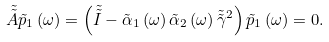<formula> <loc_0><loc_0><loc_500><loc_500>\tilde { \tilde { A } } { \tilde { p } } _ { 1 } \left ( \omega \right ) = \left ( { \tilde { \tilde { I } } - \tilde { \alpha } _ { 1 } \left ( \omega \right ) \tilde { \alpha } _ { 2 } \left ( \omega \right ) \tilde { \tilde { \gamma } } ^ { 2 } } \right ) { \tilde { p } } _ { 1 } \left ( \omega \right ) = 0 .</formula> 